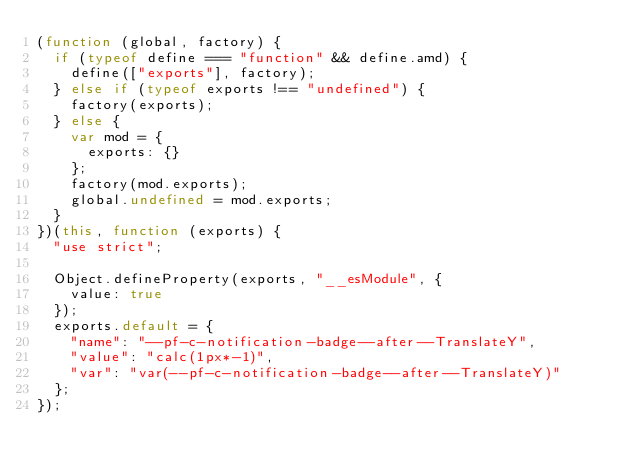<code> <loc_0><loc_0><loc_500><loc_500><_JavaScript_>(function (global, factory) {
  if (typeof define === "function" && define.amd) {
    define(["exports"], factory);
  } else if (typeof exports !== "undefined") {
    factory(exports);
  } else {
    var mod = {
      exports: {}
    };
    factory(mod.exports);
    global.undefined = mod.exports;
  }
})(this, function (exports) {
  "use strict";

  Object.defineProperty(exports, "__esModule", {
    value: true
  });
  exports.default = {
    "name": "--pf-c-notification-badge--after--TranslateY",
    "value": "calc(1px*-1)",
    "var": "var(--pf-c-notification-badge--after--TranslateY)"
  };
});</code> 